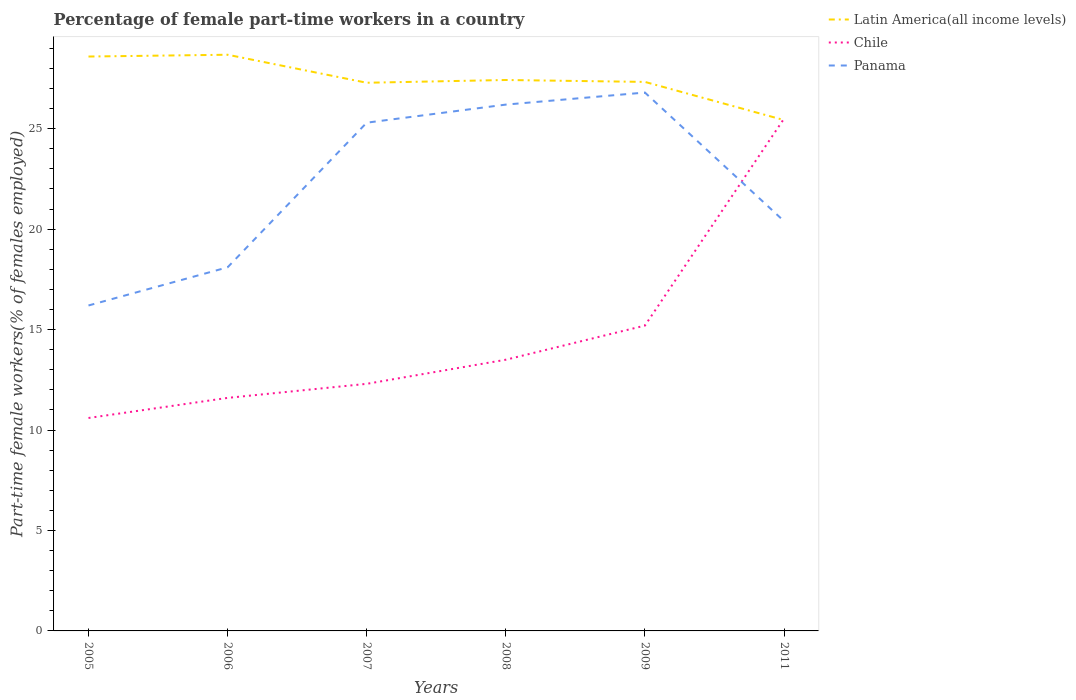Does the line corresponding to Chile intersect with the line corresponding to Panama?
Offer a terse response. Yes. Is the number of lines equal to the number of legend labels?
Offer a terse response. Yes. Across all years, what is the maximum percentage of female part-time workers in Chile?
Your answer should be compact. 10.6. In which year was the percentage of female part-time workers in Latin America(all income levels) maximum?
Your response must be concise. 2011. What is the total percentage of female part-time workers in Panama in the graph?
Your response must be concise. -0.6. What is the difference between the highest and the second highest percentage of female part-time workers in Chile?
Offer a very short reply. 14.9. What is the difference between the highest and the lowest percentage of female part-time workers in Latin America(all income levels)?
Your answer should be very brief. 2. How many years are there in the graph?
Your answer should be very brief. 6. Does the graph contain any zero values?
Make the answer very short. No. Does the graph contain grids?
Provide a short and direct response. No. How many legend labels are there?
Provide a succinct answer. 3. What is the title of the graph?
Your answer should be very brief. Percentage of female part-time workers in a country. Does "Germany" appear as one of the legend labels in the graph?
Provide a short and direct response. No. What is the label or title of the Y-axis?
Make the answer very short. Part-time female workers(% of females employed). What is the Part-time female workers(% of females employed) of Latin America(all income levels) in 2005?
Offer a very short reply. 28.59. What is the Part-time female workers(% of females employed) of Chile in 2005?
Your answer should be compact. 10.6. What is the Part-time female workers(% of females employed) of Panama in 2005?
Make the answer very short. 16.2. What is the Part-time female workers(% of females employed) in Latin America(all income levels) in 2006?
Provide a succinct answer. 28.68. What is the Part-time female workers(% of females employed) in Chile in 2006?
Keep it short and to the point. 11.6. What is the Part-time female workers(% of females employed) of Panama in 2006?
Your answer should be very brief. 18.1. What is the Part-time female workers(% of females employed) of Latin America(all income levels) in 2007?
Ensure brevity in your answer.  27.29. What is the Part-time female workers(% of females employed) of Chile in 2007?
Ensure brevity in your answer.  12.3. What is the Part-time female workers(% of females employed) of Panama in 2007?
Your answer should be very brief. 25.3. What is the Part-time female workers(% of females employed) in Latin America(all income levels) in 2008?
Provide a succinct answer. 27.42. What is the Part-time female workers(% of females employed) of Panama in 2008?
Make the answer very short. 26.2. What is the Part-time female workers(% of females employed) in Latin America(all income levels) in 2009?
Make the answer very short. 27.33. What is the Part-time female workers(% of females employed) in Chile in 2009?
Give a very brief answer. 15.2. What is the Part-time female workers(% of females employed) in Panama in 2009?
Ensure brevity in your answer.  26.8. What is the Part-time female workers(% of females employed) in Latin America(all income levels) in 2011?
Offer a terse response. 25.43. What is the Part-time female workers(% of females employed) of Chile in 2011?
Offer a terse response. 25.5. What is the Part-time female workers(% of females employed) of Panama in 2011?
Keep it short and to the point. 20.4. Across all years, what is the maximum Part-time female workers(% of females employed) of Latin America(all income levels)?
Ensure brevity in your answer.  28.68. Across all years, what is the maximum Part-time female workers(% of females employed) of Chile?
Ensure brevity in your answer.  25.5. Across all years, what is the maximum Part-time female workers(% of females employed) in Panama?
Your answer should be compact. 26.8. Across all years, what is the minimum Part-time female workers(% of females employed) in Latin America(all income levels)?
Your response must be concise. 25.43. Across all years, what is the minimum Part-time female workers(% of females employed) of Chile?
Your answer should be compact. 10.6. Across all years, what is the minimum Part-time female workers(% of females employed) of Panama?
Provide a succinct answer. 16.2. What is the total Part-time female workers(% of females employed) of Latin America(all income levels) in the graph?
Ensure brevity in your answer.  164.75. What is the total Part-time female workers(% of females employed) in Chile in the graph?
Provide a succinct answer. 88.7. What is the total Part-time female workers(% of females employed) in Panama in the graph?
Make the answer very short. 133. What is the difference between the Part-time female workers(% of females employed) in Latin America(all income levels) in 2005 and that in 2006?
Provide a short and direct response. -0.09. What is the difference between the Part-time female workers(% of females employed) in Latin America(all income levels) in 2005 and that in 2007?
Give a very brief answer. 1.3. What is the difference between the Part-time female workers(% of females employed) of Chile in 2005 and that in 2007?
Offer a very short reply. -1.7. What is the difference between the Part-time female workers(% of females employed) in Latin America(all income levels) in 2005 and that in 2008?
Your answer should be compact. 1.17. What is the difference between the Part-time female workers(% of females employed) in Chile in 2005 and that in 2008?
Keep it short and to the point. -2.9. What is the difference between the Part-time female workers(% of females employed) of Latin America(all income levels) in 2005 and that in 2009?
Your response must be concise. 1.26. What is the difference between the Part-time female workers(% of females employed) in Chile in 2005 and that in 2009?
Your answer should be very brief. -4.6. What is the difference between the Part-time female workers(% of females employed) in Latin America(all income levels) in 2005 and that in 2011?
Provide a short and direct response. 3.16. What is the difference between the Part-time female workers(% of females employed) in Chile in 2005 and that in 2011?
Offer a very short reply. -14.9. What is the difference between the Part-time female workers(% of females employed) of Panama in 2005 and that in 2011?
Make the answer very short. -4.2. What is the difference between the Part-time female workers(% of females employed) of Latin America(all income levels) in 2006 and that in 2007?
Your response must be concise. 1.39. What is the difference between the Part-time female workers(% of females employed) of Chile in 2006 and that in 2007?
Your answer should be compact. -0.7. What is the difference between the Part-time female workers(% of females employed) of Panama in 2006 and that in 2007?
Give a very brief answer. -7.2. What is the difference between the Part-time female workers(% of females employed) of Latin America(all income levels) in 2006 and that in 2008?
Your answer should be very brief. 1.26. What is the difference between the Part-time female workers(% of females employed) in Chile in 2006 and that in 2008?
Your response must be concise. -1.9. What is the difference between the Part-time female workers(% of females employed) in Panama in 2006 and that in 2008?
Your answer should be very brief. -8.1. What is the difference between the Part-time female workers(% of females employed) in Latin America(all income levels) in 2006 and that in 2009?
Provide a short and direct response. 1.35. What is the difference between the Part-time female workers(% of females employed) in Panama in 2006 and that in 2009?
Your response must be concise. -8.7. What is the difference between the Part-time female workers(% of females employed) in Latin America(all income levels) in 2006 and that in 2011?
Keep it short and to the point. 3.25. What is the difference between the Part-time female workers(% of females employed) in Chile in 2006 and that in 2011?
Offer a very short reply. -13.9. What is the difference between the Part-time female workers(% of females employed) of Panama in 2006 and that in 2011?
Your response must be concise. -2.3. What is the difference between the Part-time female workers(% of females employed) in Latin America(all income levels) in 2007 and that in 2008?
Your answer should be very brief. -0.14. What is the difference between the Part-time female workers(% of females employed) in Panama in 2007 and that in 2008?
Offer a very short reply. -0.9. What is the difference between the Part-time female workers(% of females employed) in Latin America(all income levels) in 2007 and that in 2009?
Your answer should be compact. -0.04. What is the difference between the Part-time female workers(% of females employed) of Chile in 2007 and that in 2009?
Ensure brevity in your answer.  -2.9. What is the difference between the Part-time female workers(% of females employed) of Latin America(all income levels) in 2007 and that in 2011?
Provide a succinct answer. 1.86. What is the difference between the Part-time female workers(% of females employed) in Chile in 2007 and that in 2011?
Ensure brevity in your answer.  -13.2. What is the difference between the Part-time female workers(% of females employed) in Latin America(all income levels) in 2008 and that in 2009?
Keep it short and to the point. 0.1. What is the difference between the Part-time female workers(% of females employed) in Panama in 2008 and that in 2009?
Offer a very short reply. -0.6. What is the difference between the Part-time female workers(% of females employed) of Latin America(all income levels) in 2008 and that in 2011?
Provide a succinct answer. 2. What is the difference between the Part-time female workers(% of females employed) of Chile in 2008 and that in 2011?
Provide a succinct answer. -12. What is the difference between the Part-time female workers(% of females employed) in Latin America(all income levels) in 2009 and that in 2011?
Ensure brevity in your answer.  1.9. What is the difference between the Part-time female workers(% of females employed) in Latin America(all income levels) in 2005 and the Part-time female workers(% of females employed) in Chile in 2006?
Offer a very short reply. 16.99. What is the difference between the Part-time female workers(% of females employed) of Latin America(all income levels) in 2005 and the Part-time female workers(% of females employed) of Panama in 2006?
Provide a short and direct response. 10.49. What is the difference between the Part-time female workers(% of females employed) of Chile in 2005 and the Part-time female workers(% of females employed) of Panama in 2006?
Ensure brevity in your answer.  -7.5. What is the difference between the Part-time female workers(% of females employed) of Latin America(all income levels) in 2005 and the Part-time female workers(% of females employed) of Chile in 2007?
Make the answer very short. 16.29. What is the difference between the Part-time female workers(% of females employed) of Latin America(all income levels) in 2005 and the Part-time female workers(% of females employed) of Panama in 2007?
Your response must be concise. 3.29. What is the difference between the Part-time female workers(% of females employed) in Chile in 2005 and the Part-time female workers(% of females employed) in Panama in 2007?
Offer a very short reply. -14.7. What is the difference between the Part-time female workers(% of females employed) in Latin America(all income levels) in 2005 and the Part-time female workers(% of females employed) in Chile in 2008?
Provide a short and direct response. 15.09. What is the difference between the Part-time female workers(% of females employed) of Latin America(all income levels) in 2005 and the Part-time female workers(% of females employed) of Panama in 2008?
Provide a succinct answer. 2.39. What is the difference between the Part-time female workers(% of females employed) in Chile in 2005 and the Part-time female workers(% of females employed) in Panama in 2008?
Give a very brief answer. -15.6. What is the difference between the Part-time female workers(% of females employed) of Latin America(all income levels) in 2005 and the Part-time female workers(% of females employed) of Chile in 2009?
Your answer should be compact. 13.39. What is the difference between the Part-time female workers(% of females employed) of Latin America(all income levels) in 2005 and the Part-time female workers(% of females employed) of Panama in 2009?
Your answer should be compact. 1.79. What is the difference between the Part-time female workers(% of females employed) of Chile in 2005 and the Part-time female workers(% of females employed) of Panama in 2009?
Give a very brief answer. -16.2. What is the difference between the Part-time female workers(% of females employed) in Latin America(all income levels) in 2005 and the Part-time female workers(% of females employed) in Chile in 2011?
Provide a short and direct response. 3.09. What is the difference between the Part-time female workers(% of females employed) in Latin America(all income levels) in 2005 and the Part-time female workers(% of females employed) in Panama in 2011?
Your answer should be very brief. 8.19. What is the difference between the Part-time female workers(% of females employed) in Latin America(all income levels) in 2006 and the Part-time female workers(% of females employed) in Chile in 2007?
Ensure brevity in your answer.  16.38. What is the difference between the Part-time female workers(% of females employed) in Latin America(all income levels) in 2006 and the Part-time female workers(% of females employed) in Panama in 2007?
Ensure brevity in your answer.  3.38. What is the difference between the Part-time female workers(% of females employed) of Chile in 2006 and the Part-time female workers(% of females employed) of Panama in 2007?
Offer a terse response. -13.7. What is the difference between the Part-time female workers(% of females employed) in Latin America(all income levels) in 2006 and the Part-time female workers(% of females employed) in Chile in 2008?
Keep it short and to the point. 15.18. What is the difference between the Part-time female workers(% of females employed) of Latin America(all income levels) in 2006 and the Part-time female workers(% of females employed) of Panama in 2008?
Keep it short and to the point. 2.48. What is the difference between the Part-time female workers(% of females employed) in Chile in 2006 and the Part-time female workers(% of females employed) in Panama in 2008?
Provide a short and direct response. -14.6. What is the difference between the Part-time female workers(% of females employed) in Latin America(all income levels) in 2006 and the Part-time female workers(% of females employed) in Chile in 2009?
Your response must be concise. 13.48. What is the difference between the Part-time female workers(% of females employed) of Latin America(all income levels) in 2006 and the Part-time female workers(% of females employed) of Panama in 2009?
Keep it short and to the point. 1.88. What is the difference between the Part-time female workers(% of females employed) in Chile in 2006 and the Part-time female workers(% of females employed) in Panama in 2009?
Your answer should be compact. -15.2. What is the difference between the Part-time female workers(% of females employed) of Latin America(all income levels) in 2006 and the Part-time female workers(% of females employed) of Chile in 2011?
Offer a very short reply. 3.18. What is the difference between the Part-time female workers(% of females employed) in Latin America(all income levels) in 2006 and the Part-time female workers(% of females employed) in Panama in 2011?
Provide a short and direct response. 8.28. What is the difference between the Part-time female workers(% of females employed) of Chile in 2006 and the Part-time female workers(% of females employed) of Panama in 2011?
Offer a very short reply. -8.8. What is the difference between the Part-time female workers(% of females employed) in Latin America(all income levels) in 2007 and the Part-time female workers(% of females employed) in Chile in 2008?
Ensure brevity in your answer.  13.79. What is the difference between the Part-time female workers(% of females employed) of Latin America(all income levels) in 2007 and the Part-time female workers(% of females employed) of Panama in 2008?
Your answer should be very brief. 1.09. What is the difference between the Part-time female workers(% of females employed) of Chile in 2007 and the Part-time female workers(% of females employed) of Panama in 2008?
Ensure brevity in your answer.  -13.9. What is the difference between the Part-time female workers(% of females employed) of Latin America(all income levels) in 2007 and the Part-time female workers(% of females employed) of Chile in 2009?
Offer a very short reply. 12.09. What is the difference between the Part-time female workers(% of females employed) of Latin America(all income levels) in 2007 and the Part-time female workers(% of females employed) of Panama in 2009?
Offer a terse response. 0.49. What is the difference between the Part-time female workers(% of females employed) in Chile in 2007 and the Part-time female workers(% of females employed) in Panama in 2009?
Offer a terse response. -14.5. What is the difference between the Part-time female workers(% of females employed) of Latin America(all income levels) in 2007 and the Part-time female workers(% of females employed) of Chile in 2011?
Provide a succinct answer. 1.79. What is the difference between the Part-time female workers(% of females employed) in Latin America(all income levels) in 2007 and the Part-time female workers(% of females employed) in Panama in 2011?
Provide a short and direct response. 6.89. What is the difference between the Part-time female workers(% of females employed) of Chile in 2007 and the Part-time female workers(% of females employed) of Panama in 2011?
Keep it short and to the point. -8.1. What is the difference between the Part-time female workers(% of females employed) in Latin America(all income levels) in 2008 and the Part-time female workers(% of females employed) in Chile in 2009?
Offer a very short reply. 12.22. What is the difference between the Part-time female workers(% of females employed) of Latin America(all income levels) in 2008 and the Part-time female workers(% of females employed) of Panama in 2009?
Keep it short and to the point. 0.62. What is the difference between the Part-time female workers(% of females employed) in Latin America(all income levels) in 2008 and the Part-time female workers(% of females employed) in Chile in 2011?
Your answer should be very brief. 1.92. What is the difference between the Part-time female workers(% of females employed) of Latin America(all income levels) in 2008 and the Part-time female workers(% of females employed) of Panama in 2011?
Provide a succinct answer. 7.02. What is the difference between the Part-time female workers(% of females employed) of Latin America(all income levels) in 2009 and the Part-time female workers(% of females employed) of Chile in 2011?
Keep it short and to the point. 1.83. What is the difference between the Part-time female workers(% of females employed) of Latin America(all income levels) in 2009 and the Part-time female workers(% of females employed) of Panama in 2011?
Your answer should be compact. 6.93. What is the difference between the Part-time female workers(% of females employed) in Chile in 2009 and the Part-time female workers(% of females employed) in Panama in 2011?
Provide a short and direct response. -5.2. What is the average Part-time female workers(% of females employed) in Latin America(all income levels) per year?
Keep it short and to the point. 27.46. What is the average Part-time female workers(% of females employed) of Chile per year?
Your answer should be compact. 14.78. What is the average Part-time female workers(% of females employed) in Panama per year?
Give a very brief answer. 22.17. In the year 2005, what is the difference between the Part-time female workers(% of females employed) of Latin America(all income levels) and Part-time female workers(% of females employed) of Chile?
Keep it short and to the point. 17.99. In the year 2005, what is the difference between the Part-time female workers(% of females employed) of Latin America(all income levels) and Part-time female workers(% of females employed) of Panama?
Your answer should be very brief. 12.39. In the year 2005, what is the difference between the Part-time female workers(% of females employed) in Chile and Part-time female workers(% of females employed) in Panama?
Give a very brief answer. -5.6. In the year 2006, what is the difference between the Part-time female workers(% of females employed) in Latin America(all income levels) and Part-time female workers(% of females employed) in Chile?
Your answer should be compact. 17.08. In the year 2006, what is the difference between the Part-time female workers(% of females employed) of Latin America(all income levels) and Part-time female workers(% of females employed) of Panama?
Give a very brief answer. 10.58. In the year 2006, what is the difference between the Part-time female workers(% of females employed) in Chile and Part-time female workers(% of females employed) in Panama?
Give a very brief answer. -6.5. In the year 2007, what is the difference between the Part-time female workers(% of females employed) of Latin America(all income levels) and Part-time female workers(% of females employed) of Chile?
Make the answer very short. 14.99. In the year 2007, what is the difference between the Part-time female workers(% of females employed) of Latin America(all income levels) and Part-time female workers(% of females employed) of Panama?
Your answer should be compact. 1.99. In the year 2008, what is the difference between the Part-time female workers(% of females employed) of Latin America(all income levels) and Part-time female workers(% of females employed) of Chile?
Offer a very short reply. 13.92. In the year 2008, what is the difference between the Part-time female workers(% of females employed) of Latin America(all income levels) and Part-time female workers(% of females employed) of Panama?
Your answer should be compact. 1.22. In the year 2009, what is the difference between the Part-time female workers(% of females employed) in Latin America(all income levels) and Part-time female workers(% of females employed) in Chile?
Give a very brief answer. 12.13. In the year 2009, what is the difference between the Part-time female workers(% of females employed) in Latin America(all income levels) and Part-time female workers(% of females employed) in Panama?
Provide a short and direct response. 0.53. In the year 2011, what is the difference between the Part-time female workers(% of females employed) in Latin America(all income levels) and Part-time female workers(% of females employed) in Chile?
Make the answer very short. -0.07. In the year 2011, what is the difference between the Part-time female workers(% of females employed) in Latin America(all income levels) and Part-time female workers(% of females employed) in Panama?
Offer a terse response. 5.03. What is the ratio of the Part-time female workers(% of females employed) of Chile in 2005 to that in 2006?
Offer a terse response. 0.91. What is the ratio of the Part-time female workers(% of females employed) of Panama in 2005 to that in 2006?
Make the answer very short. 0.9. What is the ratio of the Part-time female workers(% of females employed) of Latin America(all income levels) in 2005 to that in 2007?
Your answer should be compact. 1.05. What is the ratio of the Part-time female workers(% of females employed) of Chile in 2005 to that in 2007?
Your response must be concise. 0.86. What is the ratio of the Part-time female workers(% of females employed) of Panama in 2005 to that in 2007?
Provide a short and direct response. 0.64. What is the ratio of the Part-time female workers(% of females employed) of Latin America(all income levels) in 2005 to that in 2008?
Provide a succinct answer. 1.04. What is the ratio of the Part-time female workers(% of females employed) in Chile in 2005 to that in 2008?
Offer a very short reply. 0.79. What is the ratio of the Part-time female workers(% of females employed) in Panama in 2005 to that in 2008?
Give a very brief answer. 0.62. What is the ratio of the Part-time female workers(% of females employed) in Latin America(all income levels) in 2005 to that in 2009?
Give a very brief answer. 1.05. What is the ratio of the Part-time female workers(% of females employed) of Chile in 2005 to that in 2009?
Your answer should be very brief. 0.7. What is the ratio of the Part-time female workers(% of females employed) in Panama in 2005 to that in 2009?
Give a very brief answer. 0.6. What is the ratio of the Part-time female workers(% of females employed) of Latin America(all income levels) in 2005 to that in 2011?
Keep it short and to the point. 1.12. What is the ratio of the Part-time female workers(% of females employed) of Chile in 2005 to that in 2011?
Your answer should be compact. 0.42. What is the ratio of the Part-time female workers(% of females employed) in Panama in 2005 to that in 2011?
Offer a terse response. 0.79. What is the ratio of the Part-time female workers(% of females employed) of Latin America(all income levels) in 2006 to that in 2007?
Offer a terse response. 1.05. What is the ratio of the Part-time female workers(% of females employed) of Chile in 2006 to that in 2007?
Keep it short and to the point. 0.94. What is the ratio of the Part-time female workers(% of females employed) in Panama in 2006 to that in 2007?
Keep it short and to the point. 0.72. What is the ratio of the Part-time female workers(% of females employed) in Latin America(all income levels) in 2006 to that in 2008?
Give a very brief answer. 1.05. What is the ratio of the Part-time female workers(% of females employed) in Chile in 2006 to that in 2008?
Make the answer very short. 0.86. What is the ratio of the Part-time female workers(% of females employed) of Panama in 2006 to that in 2008?
Make the answer very short. 0.69. What is the ratio of the Part-time female workers(% of females employed) in Latin America(all income levels) in 2006 to that in 2009?
Ensure brevity in your answer.  1.05. What is the ratio of the Part-time female workers(% of females employed) in Chile in 2006 to that in 2009?
Your response must be concise. 0.76. What is the ratio of the Part-time female workers(% of females employed) in Panama in 2006 to that in 2009?
Provide a succinct answer. 0.68. What is the ratio of the Part-time female workers(% of females employed) in Latin America(all income levels) in 2006 to that in 2011?
Make the answer very short. 1.13. What is the ratio of the Part-time female workers(% of females employed) of Chile in 2006 to that in 2011?
Provide a succinct answer. 0.45. What is the ratio of the Part-time female workers(% of females employed) in Panama in 2006 to that in 2011?
Keep it short and to the point. 0.89. What is the ratio of the Part-time female workers(% of females employed) of Chile in 2007 to that in 2008?
Keep it short and to the point. 0.91. What is the ratio of the Part-time female workers(% of females employed) in Panama in 2007 to that in 2008?
Keep it short and to the point. 0.97. What is the ratio of the Part-time female workers(% of females employed) in Latin America(all income levels) in 2007 to that in 2009?
Offer a very short reply. 1. What is the ratio of the Part-time female workers(% of females employed) of Chile in 2007 to that in 2009?
Make the answer very short. 0.81. What is the ratio of the Part-time female workers(% of females employed) of Panama in 2007 to that in 2009?
Your answer should be very brief. 0.94. What is the ratio of the Part-time female workers(% of females employed) of Latin America(all income levels) in 2007 to that in 2011?
Offer a very short reply. 1.07. What is the ratio of the Part-time female workers(% of females employed) of Chile in 2007 to that in 2011?
Your answer should be compact. 0.48. What is the ratio of the Part-time female workers(% of females employed) in Panama in 2007 to that in 2011?
Provide a short and direct response. 1.24. What is the ratio of the Part-time female workers(% of females employed) in Chile in 2008 to that in 2009?
Give a very brief answer. 0.89. What is the ratio of the Part-time female workers(% of females employed) in Panama in 2008 to that in 2009?
Keep it short and to the point. 0.98. What is the ratio of the Part-time female workers(% of females employed) in Latin America(all income levels) in 2008 to that in 2011?
Provide a succinct answer. 1.08. What is the ratio of the Part-time female workers(% of females employed) in Chile in 2008 to that in 2011?
Your response must be concise. 0.53. What is the ratio of the Part-time female workers(% of females employed) of Panama in 2008 to that in 2011?
Make the answer very short. 1.28. What is the ratio of the Part-time female workers(% of females employed) in Latin America(all income levels) in 2009 to that in 2011?
Your answer should be compact. 1.07. What is the ratio of the Part-time female workers(% of females employed) of Chile in 2009 to that in 2011?
Offer a very short reply. 0.6. What is the ratio of the Part-time female workers(% of females employed) in Panama in 2009 to that in 2011?
Keep it short and to the point. 1.31. What is the difference between the highest and the second highest Part-time female workers(% of females employed) in Latin America(all income levels)?
Ensure brevity in your answer.  0.09. What is the difference between the highest and the second highest Part-time female workers(% of females employed) in Panama?
Offer a very short reply. 0.6. What is the difference between the highest and the lowest Part-time female workers(% of females employed) of Latin America(all income levels)?
Make the answer very short. 3.25. 